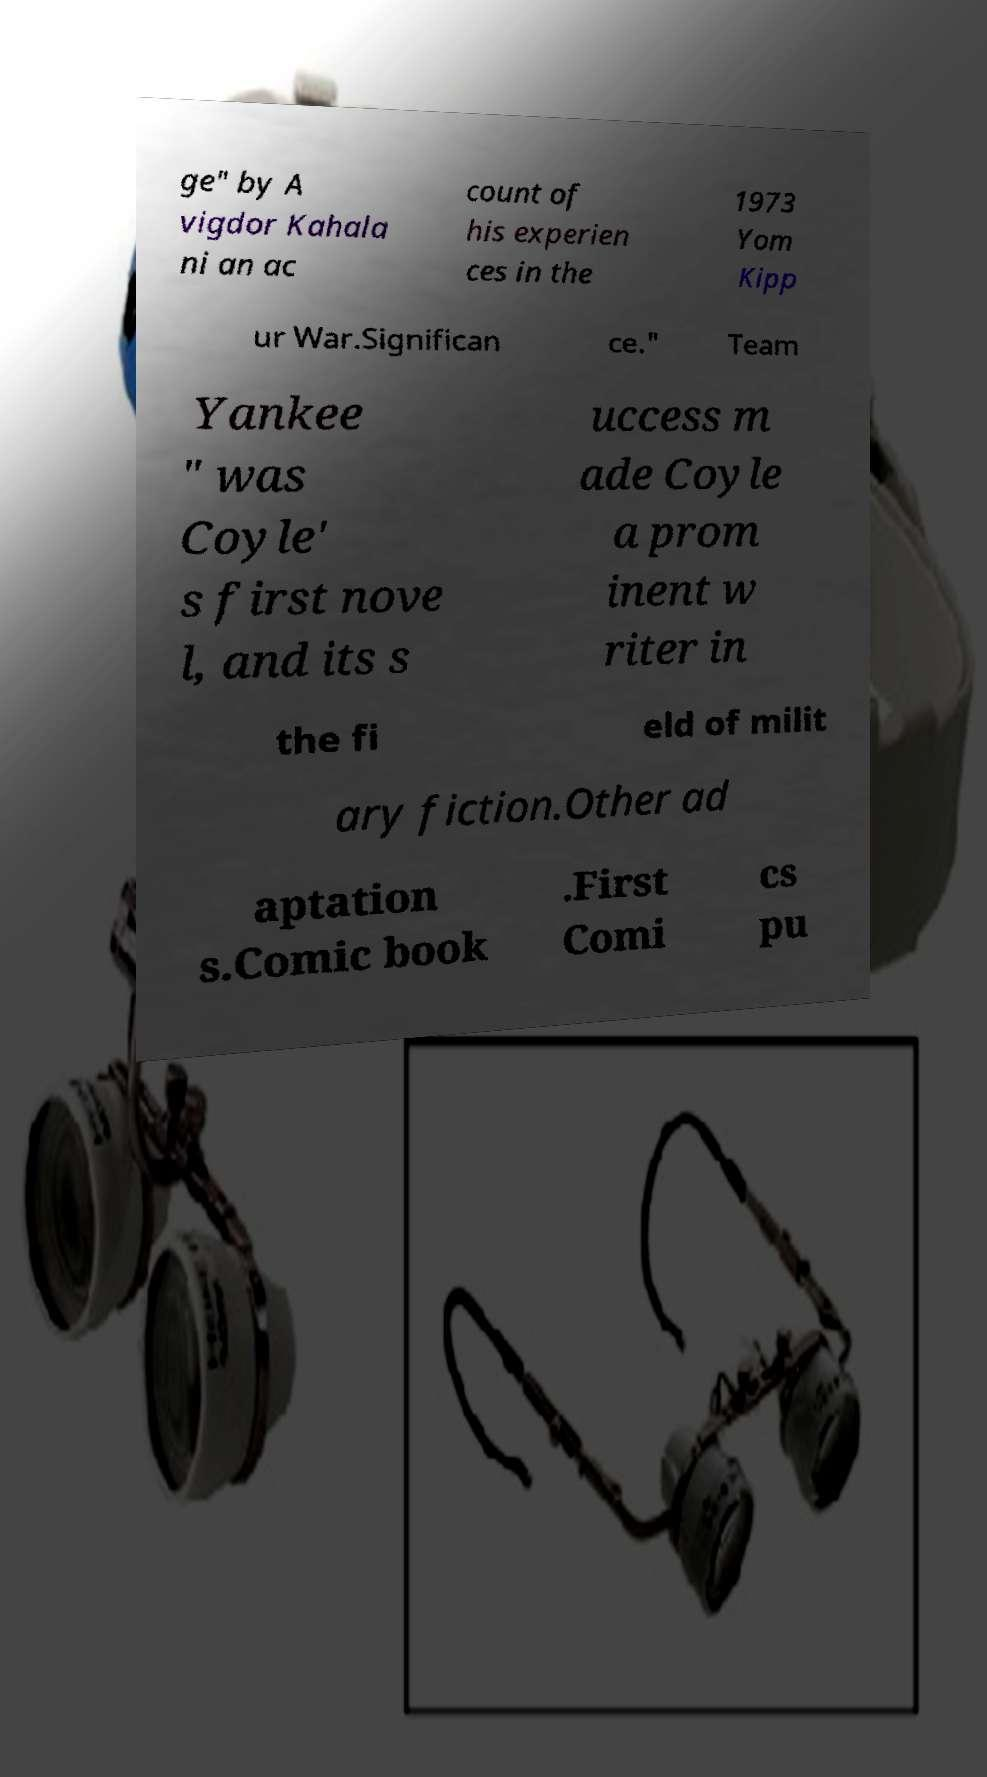Could you extract and type out the text from this image? ge" by A vigdor Kahala ni an ac count of his experien ces in the 1973 Yom Kipp ur War.Significan ce." Team Yankee " was Coyle' s first nove l, and its s uccess m ade Coyle a prom inent w riter in the fi eld of milit ary fiction.Other ad aptation s.Comic book .First Comi cs pu 